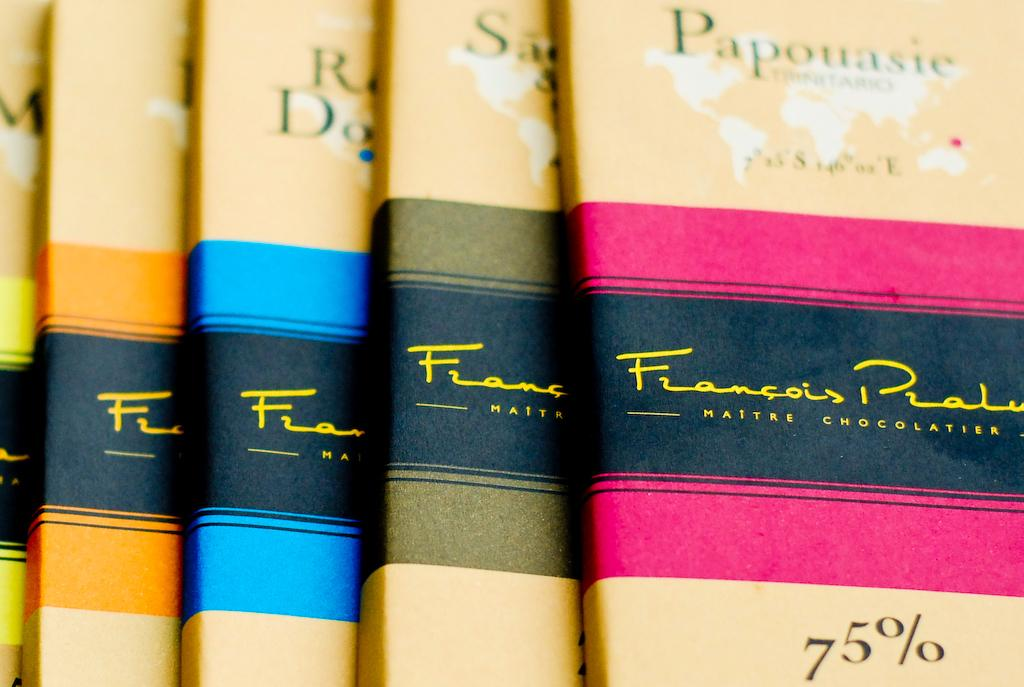<image>
Present a compact description of the photo's key features. A row of yellow books by Francois Prate. 